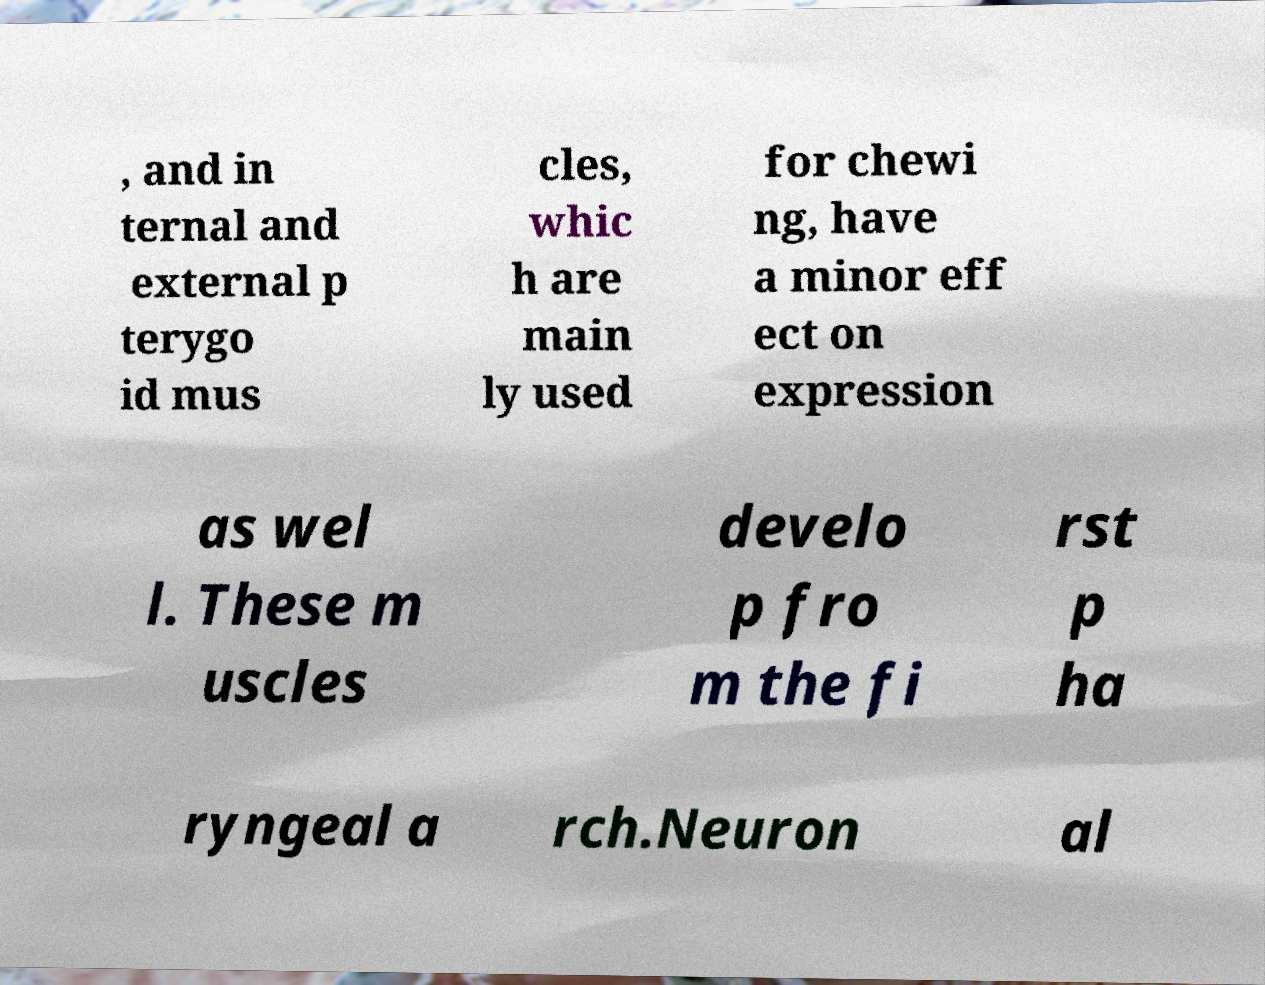Can you read and provide the text displayed in the image?This photo seems to have some interesting text. Can you extract and type it out for me? , and in ternal and external p terygo id mus cles, whic h are main ly used for chewi ng, have a minor eff ect on expression as wel l. These m uscles develo p fro m the fi rst p ha ryngeal a rch.Neuron al 